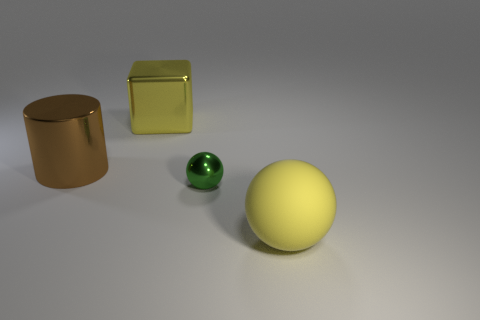How many small objects are either green rubber balls or brown metallic things?
Your answer should be very brief. 0. Are there the same number of small metallic balls behind the big yellow sphere and large brown metal objects that are on the right side of the tiny green metallic sphere?
Provide a succinct answer. No. What number of yellow spheres have the same size as the shiny cylinder?
Provide a short and direct response. 1. How many green objects are tiny spheres or large matte spheres?
Your response must be concise. 1. Are there an equal number of blocks in front of the small metal sphere and yellow rubber objects?
Provide a short and direct response. No. What is the size of the yellow thing left of the yellow rubber sphere?
Your response must be concise. Large. How many other things have the same shape as the small metal thing?
Keep it short and to the point. 1. There is a thing that is in front of the brown object and behind the big yellow matte ball; what material is it?
Offer a very short reply. Metal. Is the material of the large cylinder the same as the small sphere?
Make the answer very short. Yes. What number of matte cubes are there?
Keep it short and to the point. 0. 